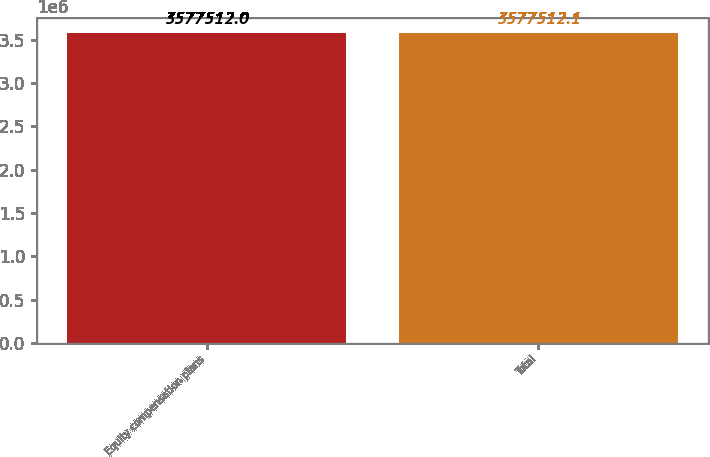Convert chart to OTSL. <chart><loc_0><loc_0><loc_500><loc_500><bar_chart><fcel>Equity compensation plans<fcel>Total<nl><fcel>3.57751e+06<fcel>3.57751e+06<nl></chart> 